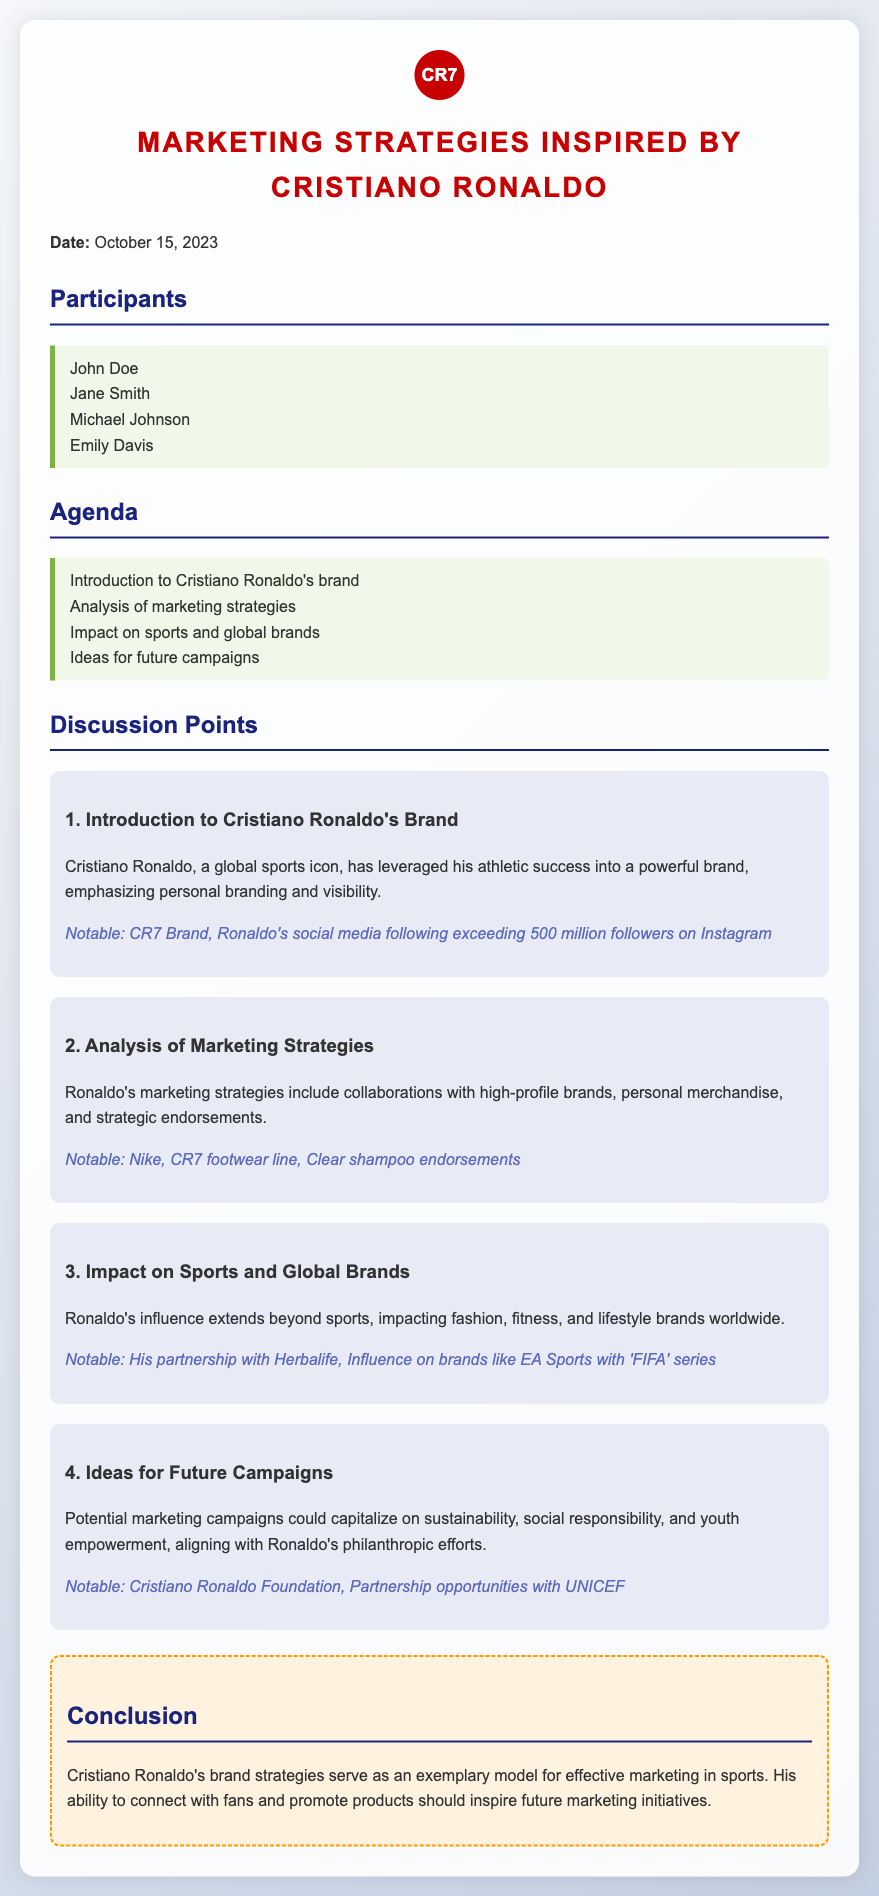what is the date of the meeting? The date of the meeting is mentioned at the top of the document.
Answer: October 15, 2023 who are the participants listed in the document? The participants are listed in a bullet format under the "Participants" section.
Answer: John Doe, Jane Smith, Michael Johnson, Emily Davis what is the first agenda item discussed? The first agenda item is listed in the "Agenda" section of the document.
Answer: Introduction to Cristiano Ronaldo's brand how many followers does Ronaldo have on Instagram? The document states Ronaldo's social media following in the "Introduction to Cristiano Ronaldo's Brand" section.
Answer: 500 million followers which brands are mentioned in the analysis of marketing strategies? The brands are listed in the "Analysis of Marketing Strategies" section, along with a description of their relationship with Ronaldo.
Answer: Nike, Clear what philanthropic opportunities are noted for future campaigns? The document notes an organization associated with Ronaldo's philanthropic efforts in the "Ideas for Future Campaigns" section.
Answer: UNICEF what overall impact does Ronaldo's influence have according to the document? The impact is discussed in the "Impact on Sports and Global Brands" section.
Answer: Fashion, fitness, and lifestyle brands what is the essence of the conclusion drawn in the document? The conclusion encapsulates the overall discussion of Ronaldo's brand strategies at the end of the document.
Answer: Exemplary model for effective marketing in sports 